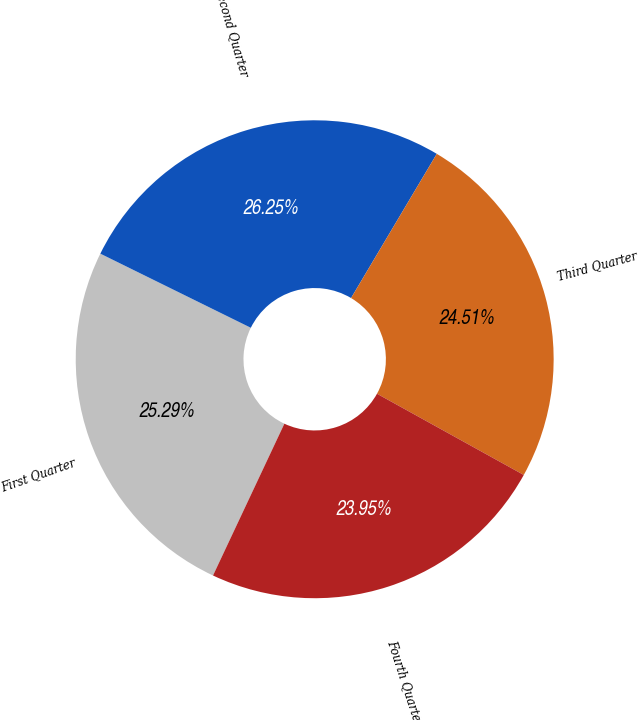Convert chart to OTSL. <chart><loc_0><loc_0><loc_500><loc_500><pie_chart><fcel>First Quarter<fcel>Second Quarter<fcel>Third Quarter<fcel>Fourth Quarter<nl><fcel>25.29%<fcel>26.25%<fcel>24.51%<fcel>23.95%<nl></chart> 